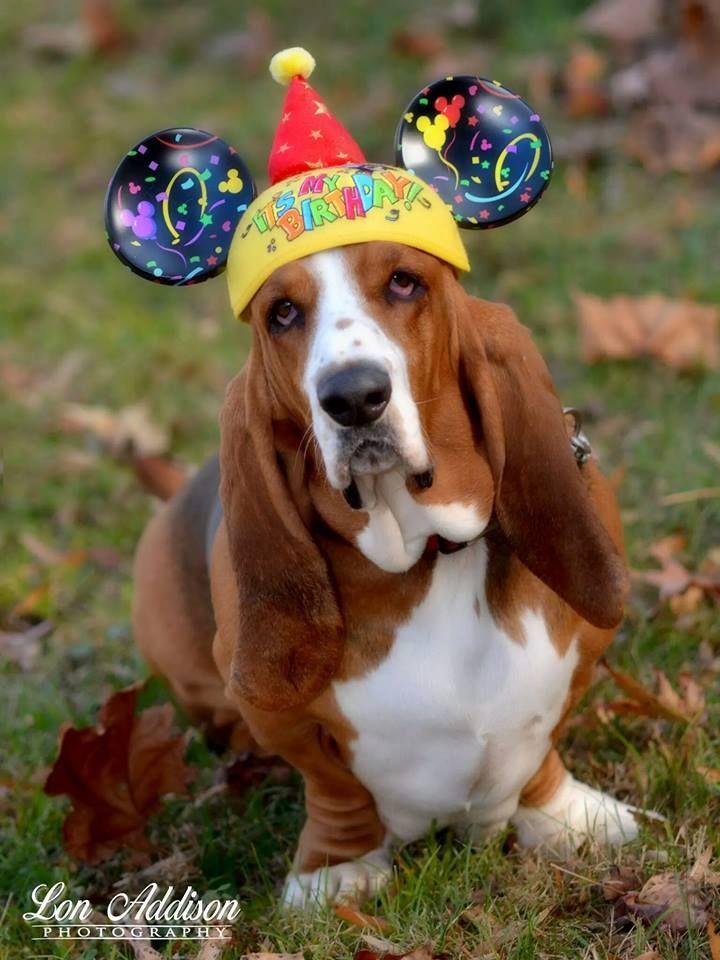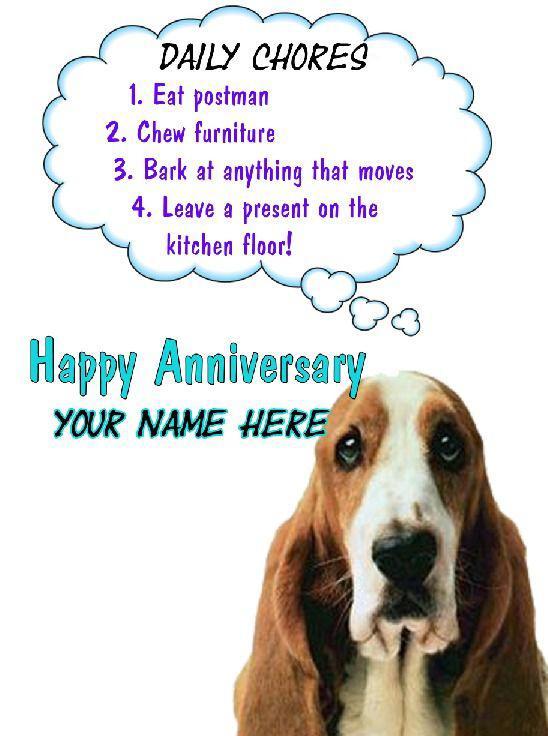The first image is the image on the left, the second image is the image on the right. Given the left and right images, does the statement "The dog in at least one of the images is outside." hold true? Answer yes or no. Yes. The first image is the image on the left, the second image is the image on the right. Analyze the images presented: Is the assertion "One of the dogs is wearing a birthday hat." valid? Answer yes or no. Yes. 